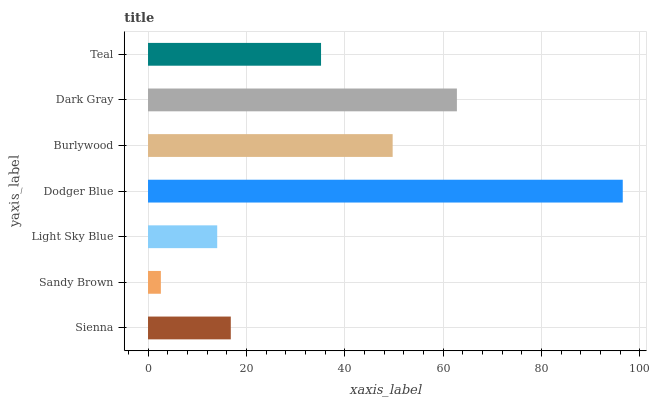Is Sandy Brown the minimum?
Answer yes or no. Yes. Is Dodger Blue the maximum?
Answer yes or no. Yes. Is Light Sky Blue the minimum?
Answer yes or no. No. Is Light Sky Blue the maximum?
Answer yes or no. No. Is Light Sky Blue greater than Sandy Brown?
Answer yes or no. Yes. Is Sandy Brown less than Light Sky Blue?
Answer yes or no. Yes. Is Sandy Brown greater than Light Sky Blue?
Answer yes or no. No. Is Light Sky Blue less than Sandy Brown?
Answer yes or no. No. Is Teal the high median?
Answer yes or no. Yes. Is Teal the low median?
Answer yes or no. Yes. Is Dark Gray the high median?
Answer yes or no. No. Is Dark Gray the low median?
Answer yes or no. No. 